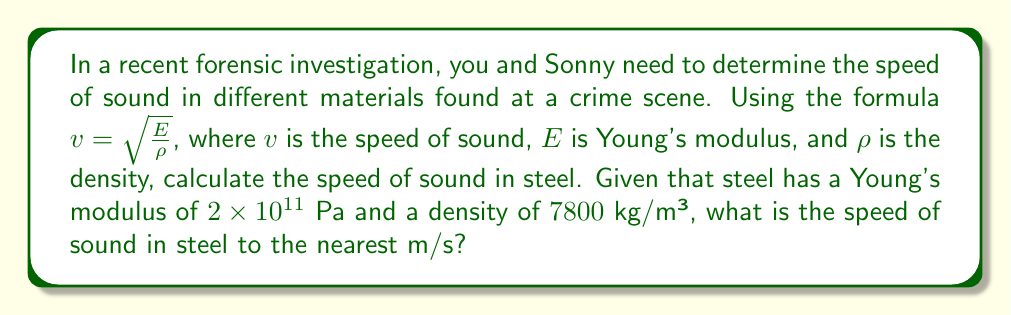Give your solution to this math problem. To solve this problem, we'll use the formula for the speed of sound in solids:

$$v = \sqrt{\frac{E}{\rho}}$$

Where:
$v$ = speed of sound
$E$ = Young's modulus
$\rho$ = density

We're given:
$E = 2 \times 10^{11}$ Pa
$\rho = 7800$ kg/m³

Let's substitute these values into the equation:

$$v = \sqrt{\frac{2 \times 10^{11}}{7800}}$$

Now, let's calculate:

$$v = \sqrt{25641025.64}$$

$$v = 5063.69$$ m/s

Rounding to the nearest m/s:

$$v \approx 5064$$ m/s
Answer: 5064 m/s 